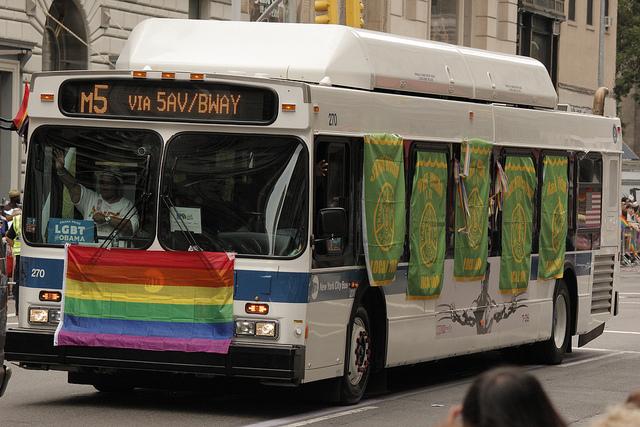Is English spoken primarily in this country?
Answer briefly. No. What country's flags are on the bus?
Answer briefly. None. What is on the front of the bus?
Write a very short answer. Flag. Could this be in Great Britain?
Quick response, please. Yes. What is the bus number?
Quick response, please. M5. What country is this?
Concise answer only. Usa. Is gay marriage wrong?
Give a very brief answer. No. How many vehicles are the street?
Give a very brief answer. 1. What words are on the top front of the bus?
Quick response, please. M5 via 5av/bway. Where is the bus going?
Be succinct. 5av/bway. What flag is most prominent?
Keep it brief. Rainbow. Is the bus blue?
Be succinct. No. What does the front of this bus have on it's logo?
Answer briefly. Rainbow. Could this bus be in a foreign country?
Write a very short answer. Yes. 